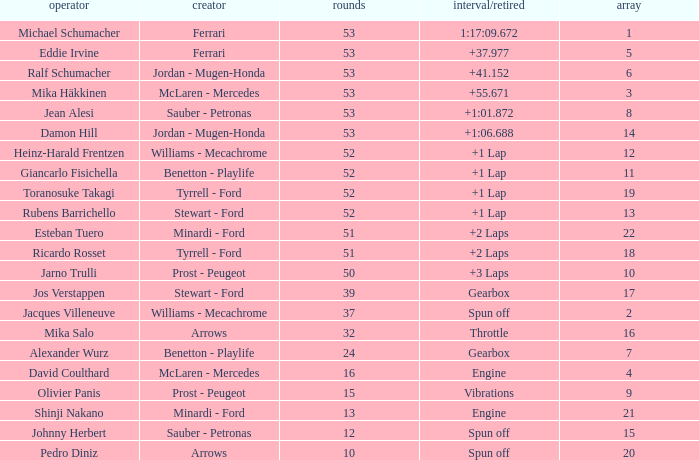What is the high lap total for pedro diniz? 10.0. 